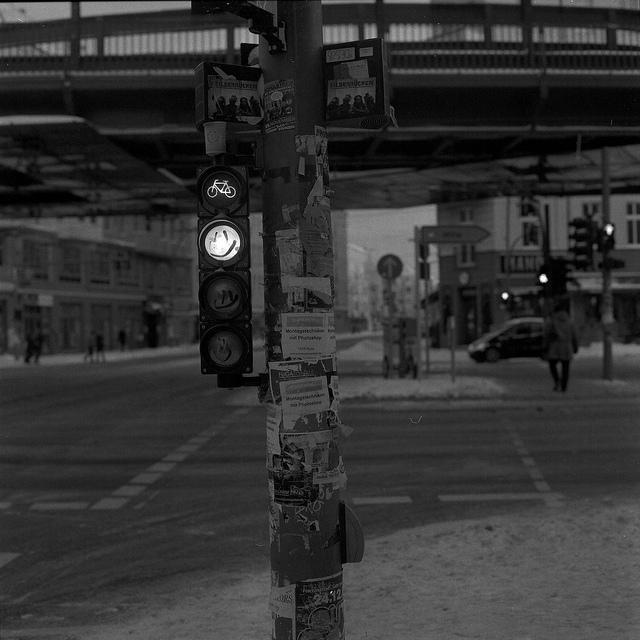How many cars are in this scene?
Give a very brief answer. 1. How many bikes are there?
Give a very brief answer. 0. 